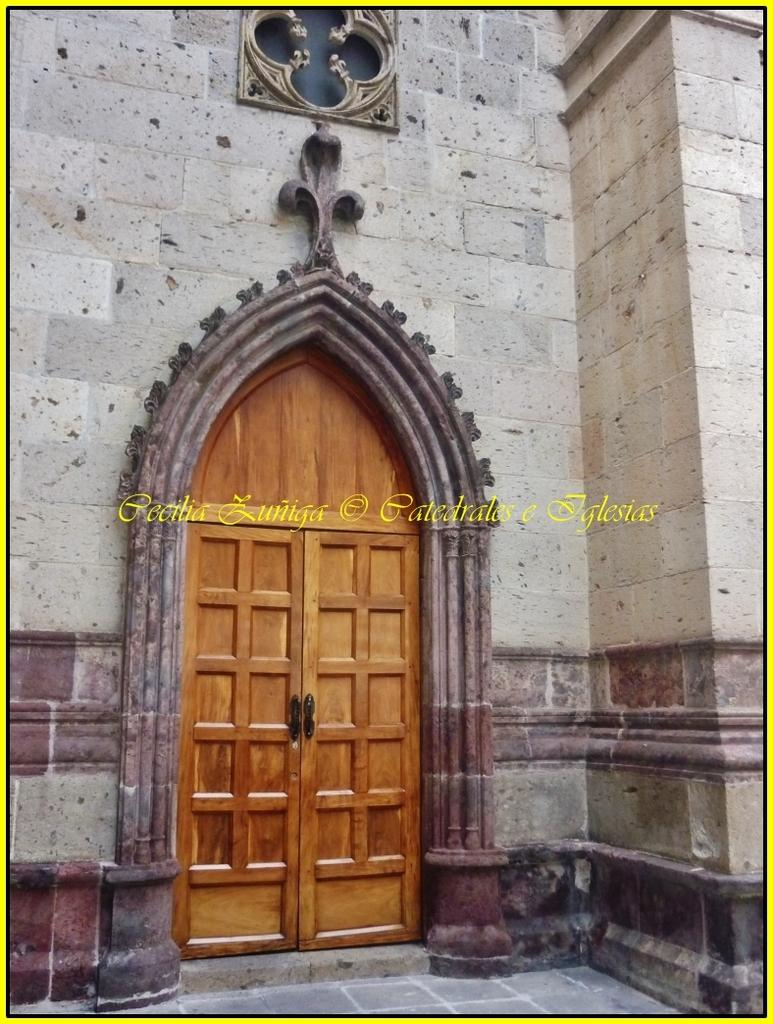What type of structure is visible in the image? There is a wall in the image. What feature is attached to the wall? There is a wooden door on the wall. What can be seen in the middle of the image? There is some text in the middle of the image. How many pies are displayed on the wall in the image? There are no pies visible in the image; it features a wall with a wooden door and text. Is there a lock on the door in the image? The image does not show a lock on the door; it only shows a wooden door on the wall. 